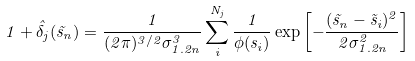Convert formula to latex. <formula><loc_0><loc_0><loc_500><loc_500>1 + { \hat { \delta } } _ { j } ( { \vec { s } } _ { n } ) = \frac { 1 } { ( 2 \pi ) ^ { 3 / 2 } \sigma _ { 1 . 2 n } ^ { 3 } } \sum _ { i } ^ { N _ { j } } \frac { 1 } { \phi ( s _ { i } ) } \exp \left [ - \frac { ( { \vec { s } } _ { n } - { \vec { s } } _ { i } ) ^ { 2 } } { 2 \sigma _ { 1 . 2 n } ^ { 2 } } \right ]</formula> 